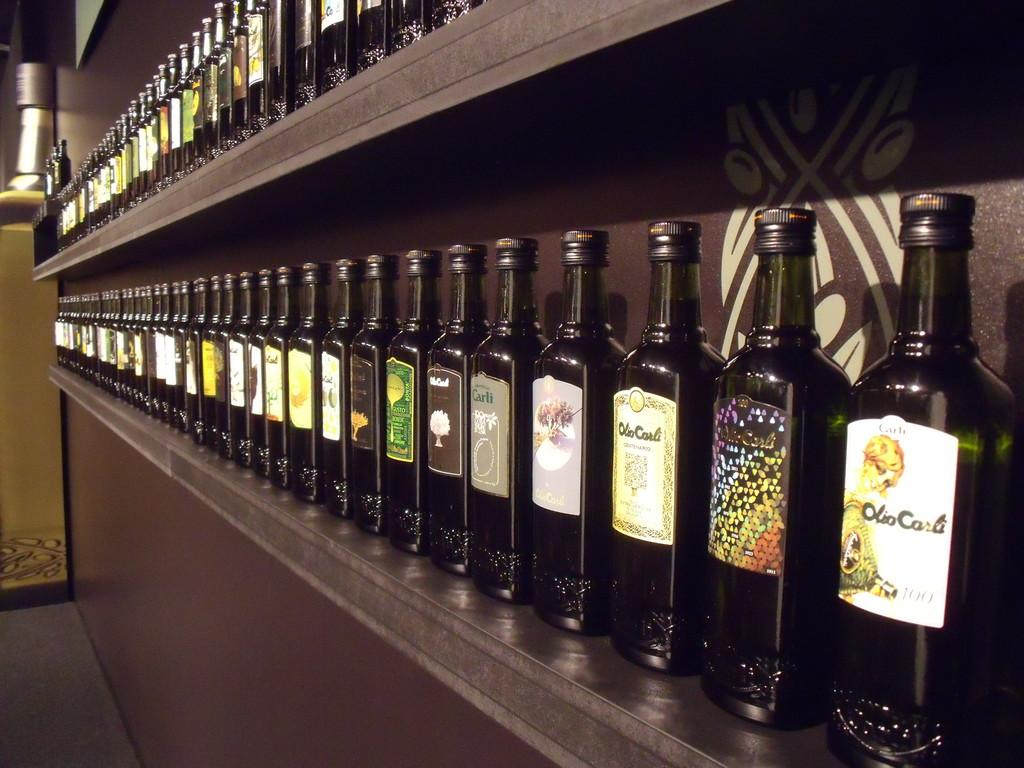What is one of the main features in the image? There is a wall in the image. What can be seen on the wall in the image? There are bottles in racks on the wall in the image. Can you describe what is visible on the floor in the background of the image? There are objects visible on the floor in the background. How many tomatoes can be seen hanging from the wall in the image? There are no tomatoes visible in the image; it features a wall with bottles in racks. What type of monkey is sitting on the wall in the image? There is no monkey present in the image; it only features a wall with bottles in racks and objects on the floor in the background. 